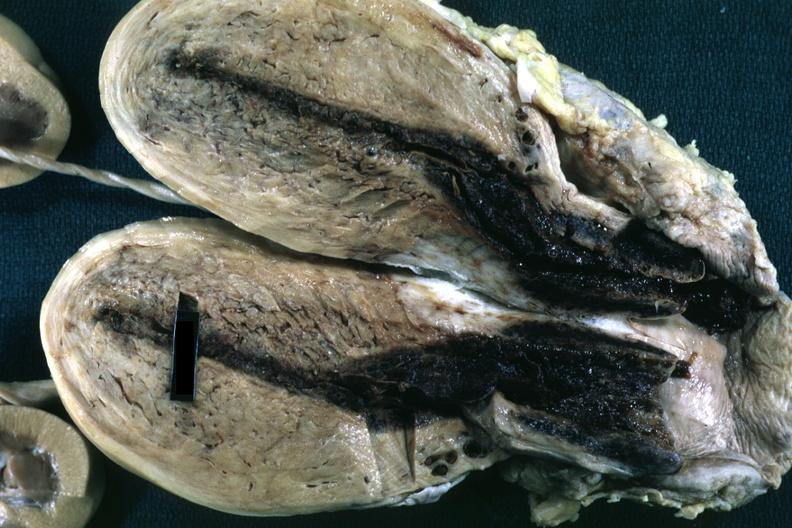what is present?
Answer the question using a single word or phrase. Female reproductive 